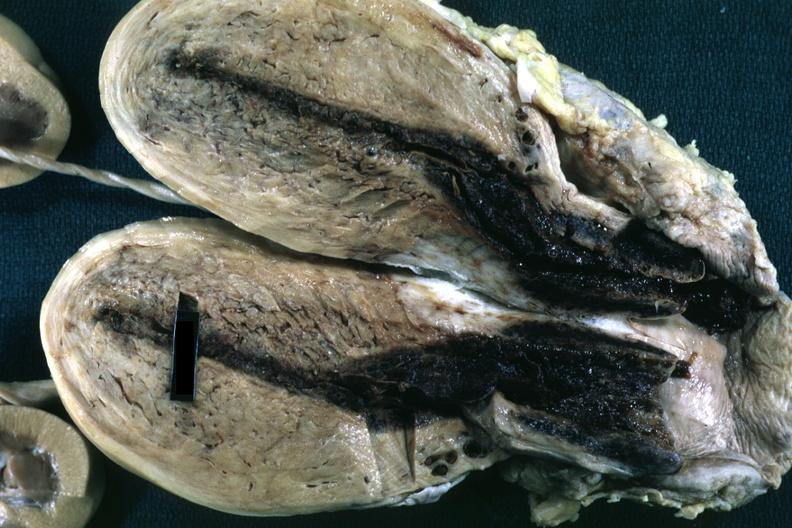what is present?
Answer the question using a single word or phrase. Female reproductive 